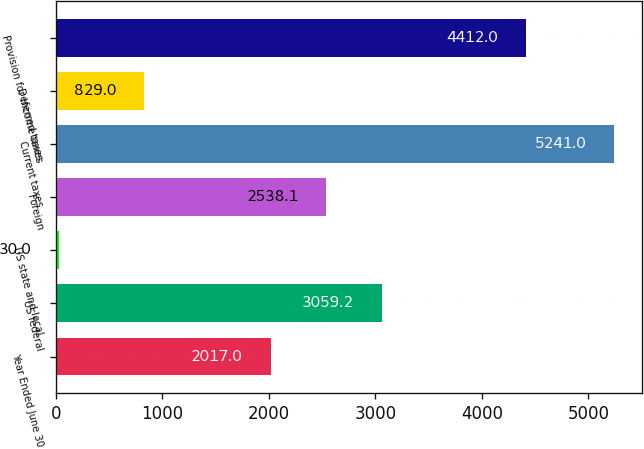Convert chart to OTSL. <chart><loc_0><loc_0><loc_500><loc_500><bar_chart><fcel>Year Ended June 30<fcel>US federal<fcel>US state and local<fcel>Foreign<fcel>Current taxes<fcel>Deferred taxes<fcel>Provision for income taxes<nl><fcel>2017<fcel>3059.2<fcel>30<fcel>2538.1<fcel>5241<fcel>829<fcel>4412<nl></chart> 